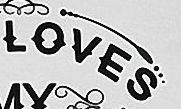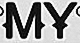What words can you see in these images in sequence, separated by a semicolon? LOVES; MY 